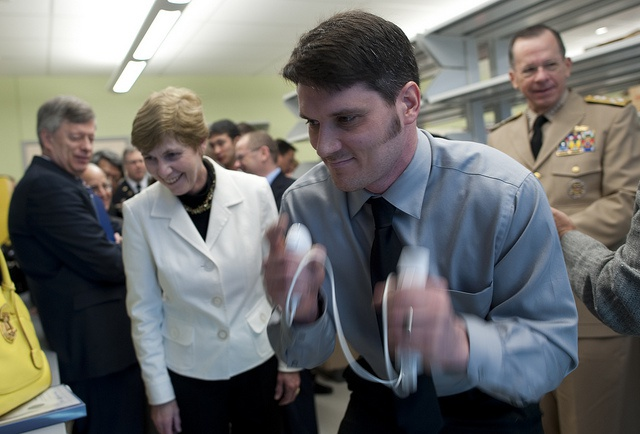Describe the objects in this image and their specific colors. I can see people in darkgray, black, and gray tones, people in darkgray, black, lightgray, and gray tones, people in darkgray, black, gray, and navy tones, people in darkgray, gray, and tan tones, and people in darkgray, gray, black, and darkblue tones in this image. 